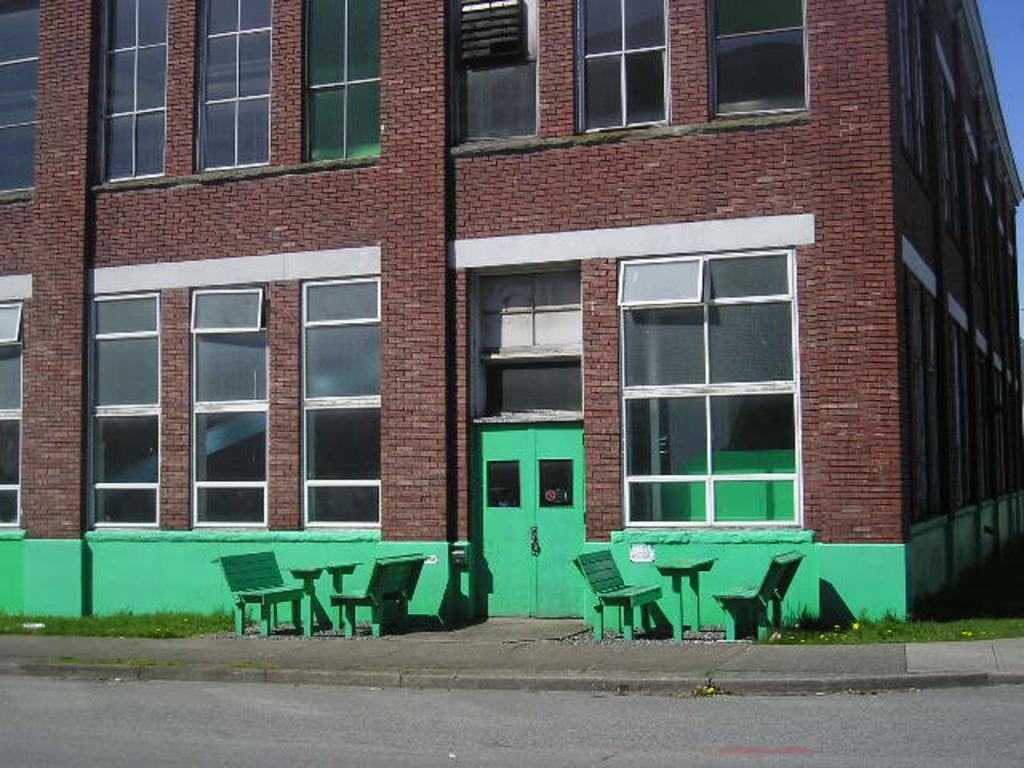What type of structure is present in the image? There is a building in the image. What objects can be seen on the tables in the image? Glasses are visible in the image. What feature allows access to the building? There is a door in the image. What type of furniture is present in the image? There are tables and benches in the image. What is the outdoor environment like in the image? There is a road and grass visible in the image. Where is the market located in the image? There is no market present in the image. What type of tray is being used to serve food on the tables? There is no tray visible in the image; only glasses are present on the tables. 